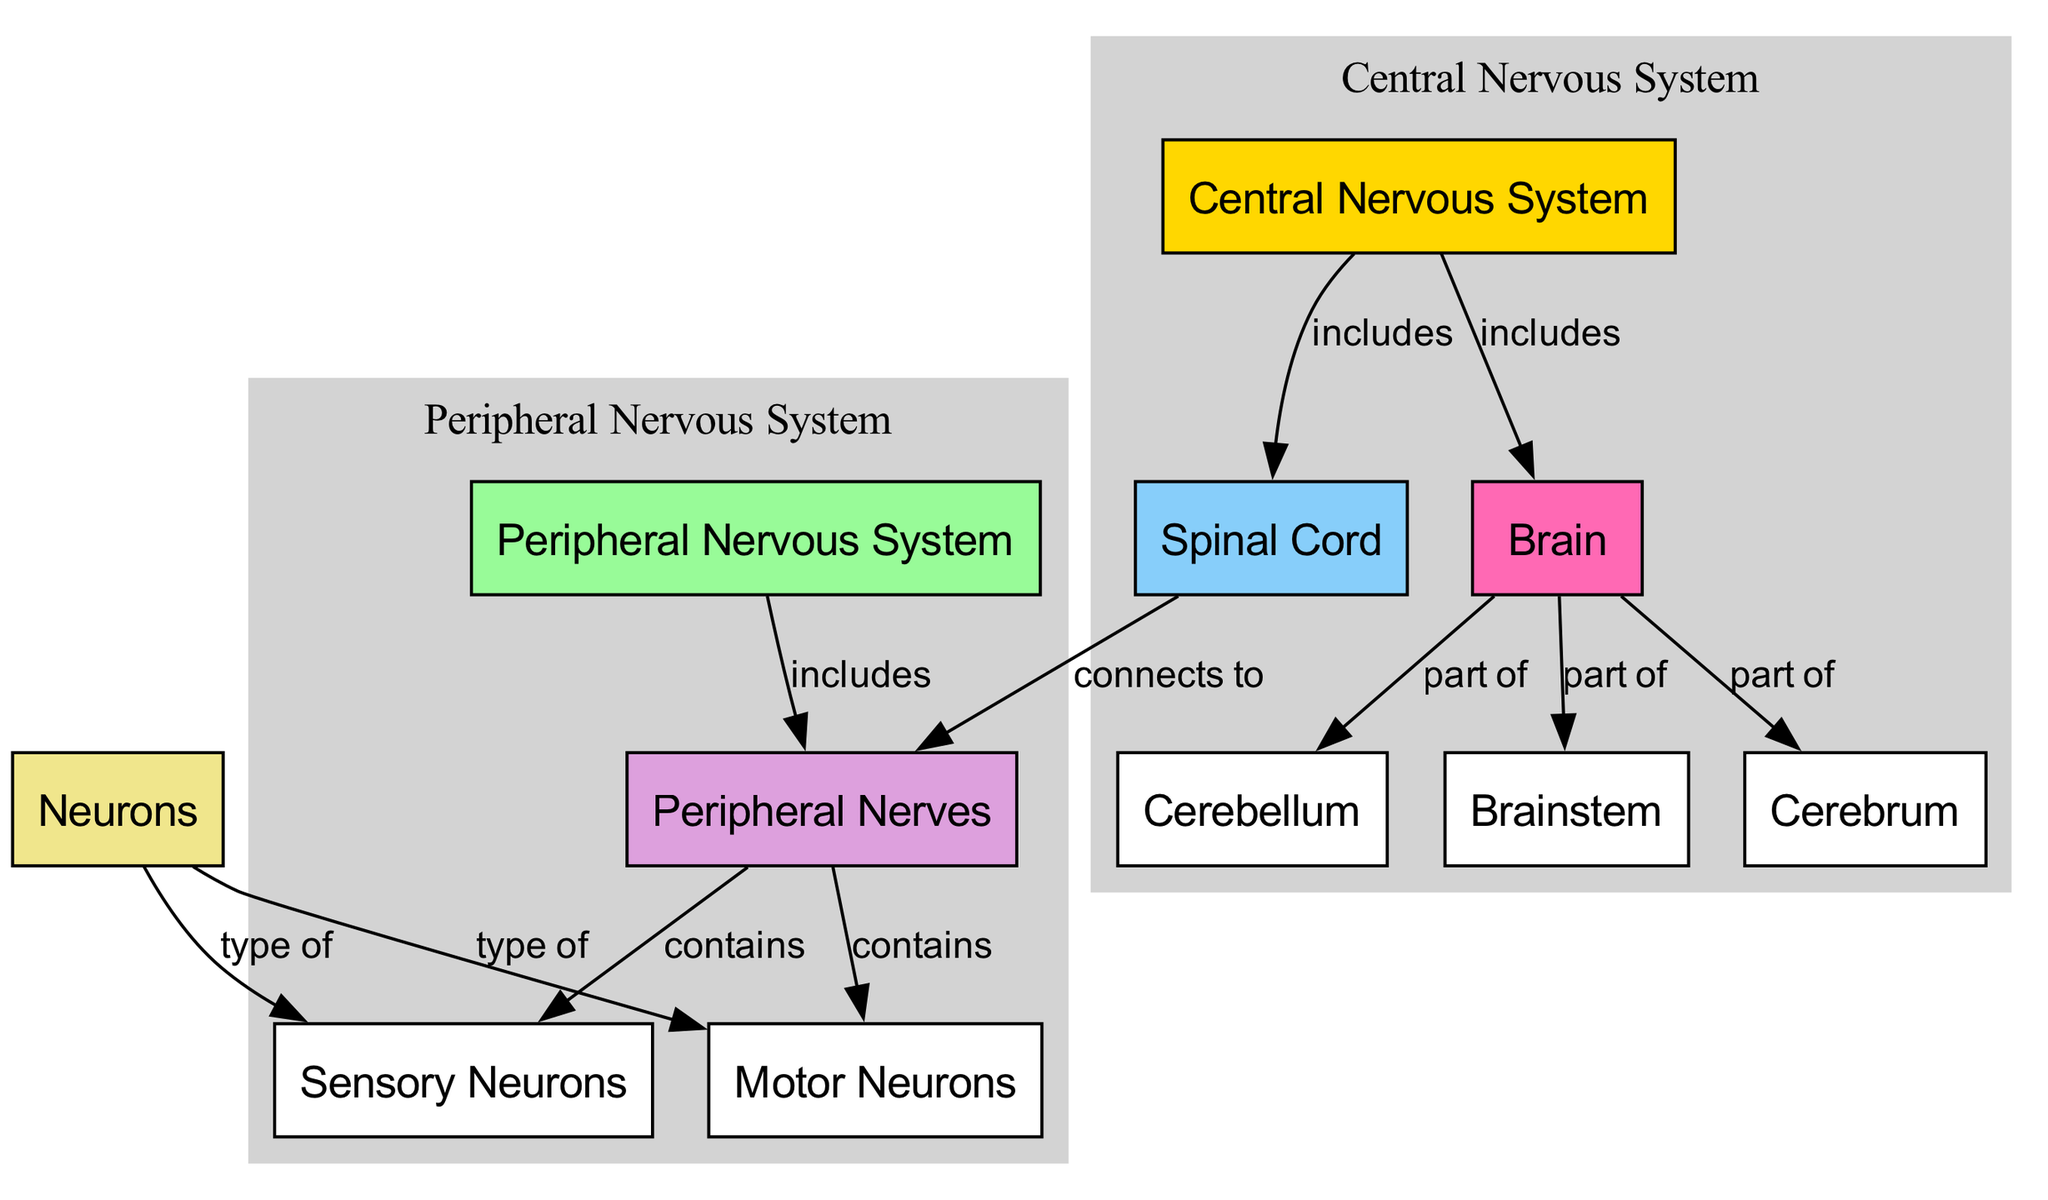What are the two main parts of the nervous system? The diagram shows the Central Nervous System and the Peripheral Nervous System as the two primary components of the nervous system. They are visually distinguished by different colors, with the Central Nervous System in gold and the Peripheral Nervous System in pale green.
Answer: Central Nervous System, Peripheral Nervous System How many parts are there in the brain? The brain is represented in the diagram as having three parts: the Cerebrum, the Cerebellum, and the Brainstem. Each part is connected to the Brain node, indicating they are subdivisions of the brain.
Answer: 3 What does the spinal cord connect to? According to the diagram, the spinal cord is shown to connect to the Peripheral Nerves, which indicates its role in linking the Central Nervous System to the body via nerve pathways.
Answer: Peripheral Nerves Which type of neurons do the nerves contain? The diagram indicates that Peripheral Nerves contain two specific types of neurons: Sensory Neurons and Motor Neurons. Both types are connected to the Nerves, signifying their presence within this structure.
Answer: Sensory Neurons, Motor Neurons What is included in the Central Nervous System? The diagram identifies the components of the Central Nervous System as the Brain and the Spinal Cord. These elements are connected to the Central Nervous System node, which shows its structure clearly.
Answer: Brain, Spinal Cord What type of neuron is a Sensory Neuron? From the diagram, the Sensory Neuron is depicted as a type of Neuron. It is specifically categorized under the Neurons node, which indicates its classification within the broader group of neurons.
Answer: Type of Neuron What part of the brain is the Cerebellum? The Cerebellum is identified in the diagram as part of the Brain, illustrating that it is one of the three main components that make up the overall structure of the brain.
Answer: Part of Brain How many edges connect to the brain node? The brain node has three edges connecting to the Cerebrum, Cerebellum, and Brainstem. This indicates the brain's subdivisions, demonstrating a clear connection visually represented in the diagram.
Answer: 3 